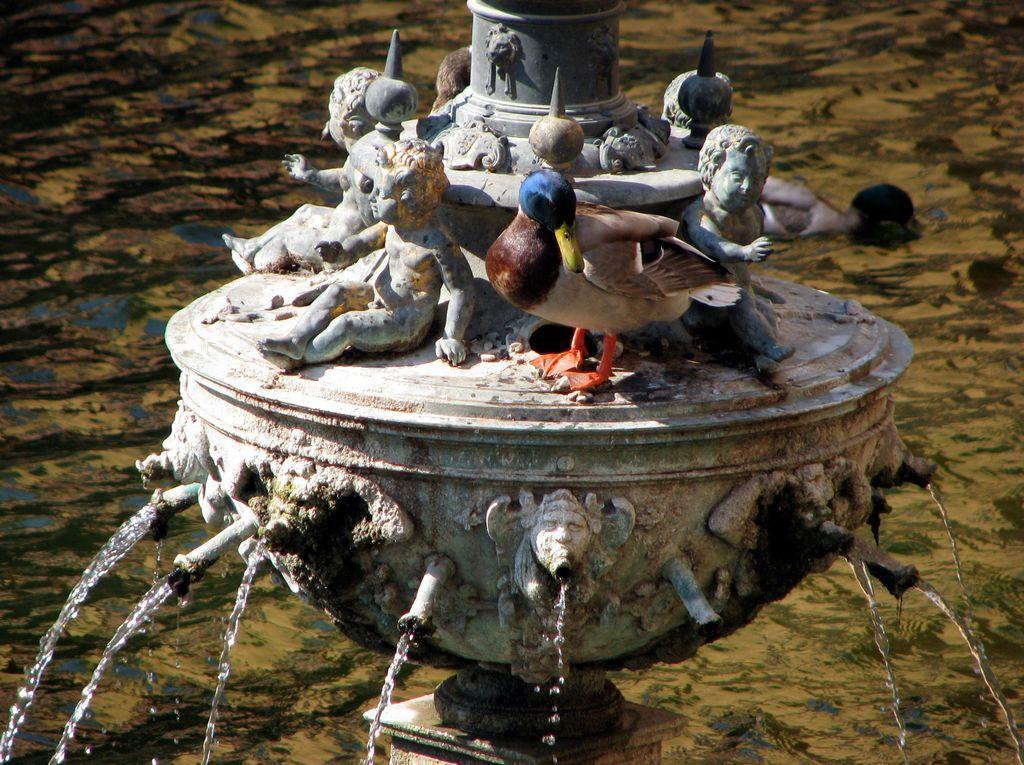Can you describe this image briefly? In the center of the image we can see the fountain, sculptures and a few other objects. In the background, we can see water, one object in the water and a few other objects. 